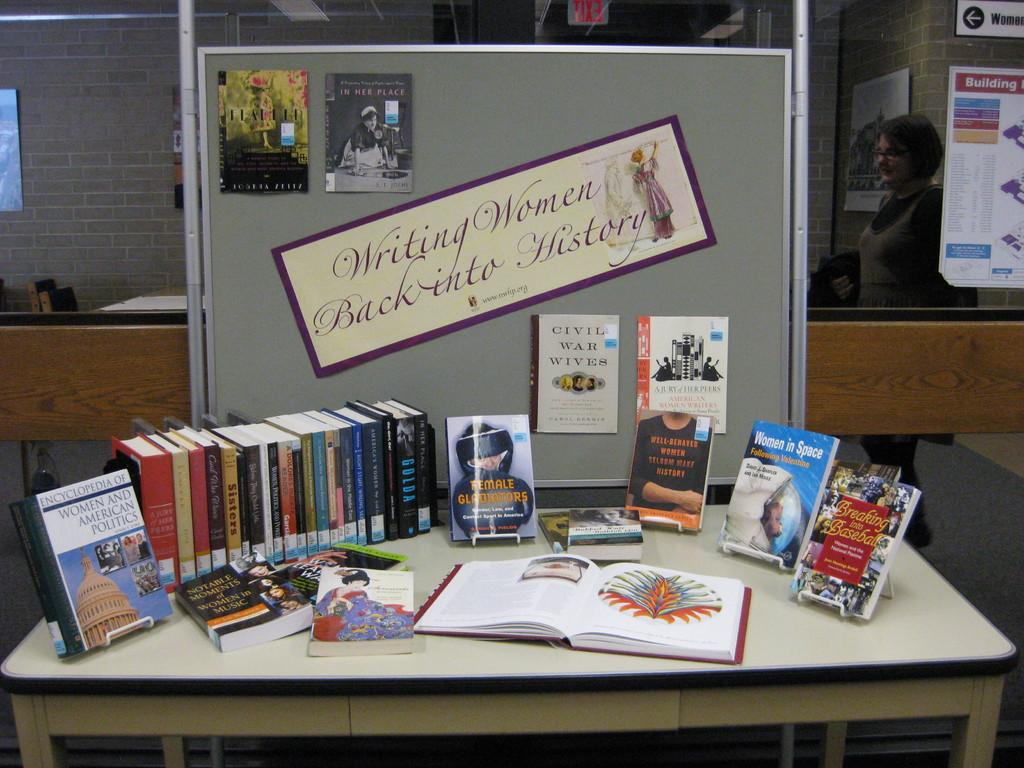<image>
Render a clear and concise summary of the photo. A display of books is arranged under a banner about women in history. 